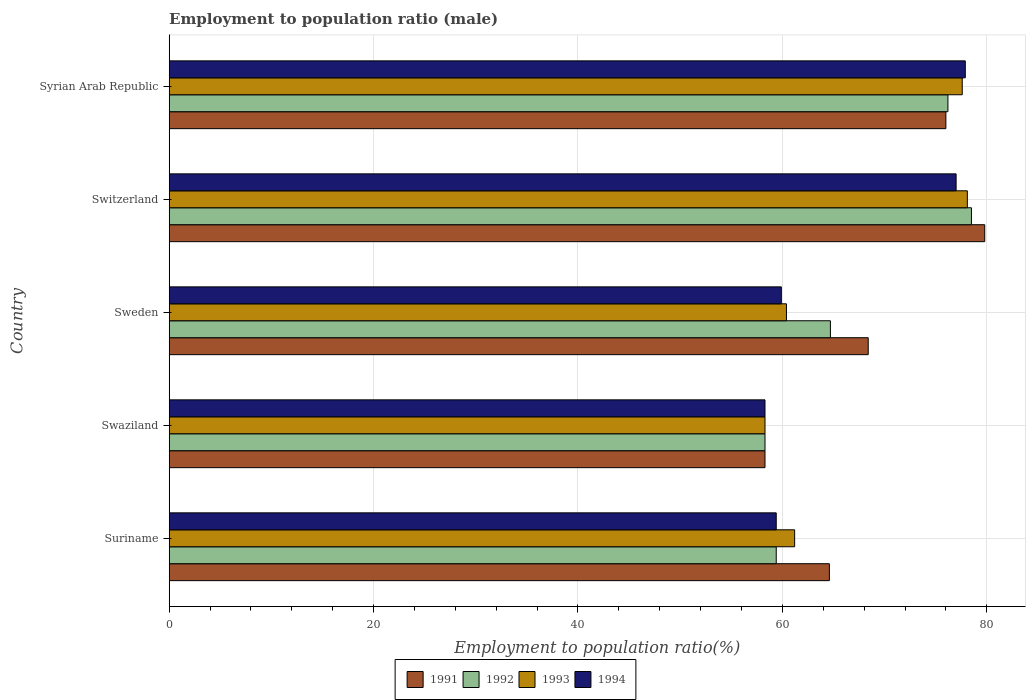How many groups of bars are there?
Your answer should be compact. 5. Are the number of bars on each tick of the Y-axis equal?
Your answer should be very brief. Yes. How many bars are there on the 5th tick from the top?
Provide a succinct answer. 4. What is the label of the 1st group of bars from the top?
Your response must be concise. Syrian Arab Republic. What is the employment to population ratio in 1992 in Syrian Arab Republic?
Make the answer very short. 76.2. Across all countries, what is the maximum employment to population ratio in 1993?
Keep it short and to the point. 78.1. Across all countries, what is the minimum employment to population ratio in 1993?
Provide a succinct answer. 58.3. In which country was the employment to population ratio in 1993 maximum?
Ensure brevity in your answer.  Switzerland. In which country was the employment to population ratio in 1992 minimum?
Keep it short and to the point. Swaziland. What is the total employment to population ratio in 1991 in the graph?
Your response must be concise. 347.1. What is the difference between the employment to population ratio in 1994 in Suriname and that in Sweden?
Make the answer very short. -0.5. What is the difference between the employment to population ratio in 1991 in Syrian Arab Republic and the employment to population ratio in 1992 in Suriname?
Ensure brevity in your answer.  16.6. What is the average employment to population ratio in 1994 per country?
Offer a terse response. 66.5. What is the difference between the employment to population ratio in 1994 and employment to population ratio in 1992 in Syrian Arab Republic?
Make the answer very short. 1.7. In how many countries, is the employment to population ratio in 1994 greater than 64 %?
Your answer should be very brief. 2. What is the ratio of the employment to population ratio in 1992 in Swaziland to that in Switzerland?
Make the answer very short. 0.74. Is the employment to population ratio in 1991 in Suriname less than that in Sweden?
Your response must be concise. Yes. Is the difference between the employment to population ratio in 1994 in Suriname and Sweden greater than the difference between the employment to population ratio in 1992 in Suriname and Sweden?
Your answer should be compact. Yes. What is the difference between the highest and the second highest employment to population ratio in 1991?
Your answer should be compact. 3.8. What is the difference between the highest and the lowest employment to population ratio in 1993?
Offer a very short reply. 19.8. What does the 2nd bar from the top in Suriname represents?
Keep it short and to the point. 1993. Is it the case that in every country, the sum of the employment to population ratio in 1992 and employment to population ratio in 1991 is greater than the employment to population ratio in 1994?
Your answer should be very brief. Yes. How many bars are there?
Your answer should be compact. 20. Are all the bars in the graph horizontal?
Keep it short and to the point. Yes. What is the difference between two consecutive major ticks on the X-axis?
Your response must be concise. 20. Are the values on the major ticks of X-axis written in scientific E-notation?
Your response must be concise. No. Does the graph contain any zero values?
Your answer should be very brief. No. Where does the legend appear in the graph?
Your answer should be compact. Bottom center. How are the legend labels stacked?
Your answer should be very brief. Horizontal. What is the title of the graph?
Offer a terse response. Employment to population ratio (male). What is the label or title of the X-axis?
Your answer should be very brief. Employment to population ratio(%). What is the Employment to population ratio(%) of 1991 in Suriname?
Provide a short and direct response. 64.6. What is the Employment to population ratio(%) in 1992 in Suriname?
Give a very brief answer. 59.4. What is the Employment to population ratio(%) of 1993 in Suriname?
Your answer should be very brief. 61.2. What is the Employment to population ratio(%) in 1994 in Suriname?
Provide a short and direct response. 59.4. What is the Employment to population ratio(%) in 1991 in Swaziland?
Keep it short and to the point. 58.3. What is the Employment to population ratio(%) in 1992 in Swaziland?
Offer a terse response. 58.3. What is the Employment to population ratio(%) in 1993 in Swaziland?
Ensure brevity in your answer.  58.3. What is the Employment to population ratio(%) of 1994 in Swaziland?
Provide a short and direct response. 58.3. What is the Employment to population ratio(%) of 1991 in Sweden?
Provide a succinct answer. 68.4. What is the Employment to population ratio(%) in 1992 in Sweden?
Your answer should be very brief. 64.7. What is the Employment to population ratio(%) in 1993 in Sweden?
Your response must be concise. 60.4. What is the Employment to population ratio(%) of 1994 in Sweden?
Provide a succinct answer. 59.9. What is the Employment to population ratio(%) of 1991 in Switzerland?
Your answer should be very brief. 79.8. What is the Employment to population ratio(%) in 1992 in Switzerland?
Your response must be concise. 78.5. What is the Employment to population ratio(%) of 1993 in Switzerland?
Provide a succinct answer. 78.1. What is the Employment to population ratio(%) of 1994 in Switzerland?
Your response must be concise. 77. What is the Employment to population ratio(%) of 1991 in Syrian Arab Republic?
Ensure brevity in your answer.  76. What is the Employment to population ratio(%) in 1992 in Syrian Arab Republic?
Offer a terse response. 76.2. What is the Employment to population ratio(%) in 1993 in Syrian Arab Republic?
Provide a succinct answer. 77.6. What is the Employment to population ratio(%) in 1994 in Syrian Arab Republic?
Give a very brief answer. 77.9. Across all countries, what is the maximum Employment to population ratio(%) in 1991?
Ensure brevity in your answer.  79.8. Across all countries, what is the maximum Employment to population ratio(%) in 1992?
Your answer should be very brief. 78.5. Across all countries, what is the maximum Employment to population ratio(%) in 1993?
Keep it short and to the point. 78.1. Across all countries, what is the maximum Employment to population ratio(%) in 1994?
Offer a very short reply. 77.9. Across all countries, what is the minimum Employment to population ratio(%) of 1991?
Provide a succinct answer. 58.3. Across all countries, what is the minimum Employment to population ratio(%) in 1992?
Offer a very short reply. 58.3. Across all countries, what is the minimum Employment to population ratio(%) in 1993?
Make the answer very short. 58.3. Across all countries, what is the minimum Employment to population ratio(%) of 1994?
Your answer should be very brief. 58.3. What is the total Employment to population ratio(%) in 1991 in the graph?
Give a very brief answer. 347.1. What is the total Employment to population ratio(%) of 1992 in the graph?
Keep it short and to the point. 337.1. What is the total Employment to population ratio(%) of 1993 in the graph?
Provide a short and direct response. 335.6. What is the total Employment to population ratio(%) in 1994 in the graph?
Provide a succinct answer. 332.5. What is the difference between the Employment to population ratio(%) of 1993 in Suriname and that in Swaziland?
Ensure brevity in your answer.  2.9. What is the difference between the Employment to population ratio(%) of 1991 in Suriname and that in Sweden?
Provide a succinct answer. -3.8. What is the difference between the Employment to population ratio(%) in 1992 in Suriname and that in Sweden?
Provide a short and direct response. -5.3. What is the difference between the Employment to population ratio(%) in 1993 in Suriname and that in Sweden?
Your answer should be very brief. 0.8. What is the difference between the Employment to population ratio(%) of 1994 in Suriname and that in Sweden?
Your answer should be compact. -0.5. What is the difference between the Employment to population ratio(%) of 1991 in Suriname and that in Switzerland?
Your response must be concise. -15.2. What is the difference between the Employment to population ratio(%) in 1992 in Suriname and that in Switzerland?
Provide a short and direct response. -19.1. What is the difference between the Employment to population ratio(%) in 1993 in Suriname and that in Switzerland?
Keep it short and to the point. -16.9. What is the difference between the Employment to population ratio(%) in 1994 in Suriname and that in Switzerland?
Provide a short and direct response. -17.6. What is the difference between the Employment to population ratio(%) in 1991 in Suriname and that in Syrian Arab Republic?
Make the answer very short. -11.4. What is the difference between the Employment to population ratio(%) of 1992 in Suriname and that in Syrian Arab Republic?
Offer a terse response. -16.8. What is the difference between the Employment to population ratio(%) of 1993 in Suriname and that in Syrian Arab Republic?
Offer a very short reply. -16.4. What is the difference between the Employment to population ratio(%) in 1994 in Suriname and that in Syrian Arab Republic?
Provide a short and direct response. -18.5. What is the difference between the Employment to population ratio(%) of 1994 in Swaziland and that in Sweden?
Ensure brevity in your answer.  -1.6. What is the difference between the Employment to population ratio(%) of 1991 in Swaziland and that in Switzerland?
Provide a succinct answer. -21.5. What is the difference between the Employment to population ratio(%) of 1992 in Swaziland and that in Switzerland?
Offer a very short reply. -20.2. What is the difference between the Employment to population ratio(%) in 1993 in Swaziland and that in Switzerland?
Your answer should be compact. -19.8. What is the difference between the Employment to population ratio(%) of 1994 in Swaziland and that in Switzerland?
Ensure brevity in your answer.  -18.7. What is the difference between the Employment to population ratio(%) in 1991 in Swaziland and that in Syrian Arab Republic?
Your answer should be compact. -17.7. What is the difference between the Employment to population ratio(%) of 1992 in Swaziland and that in Syrian Arab Republic?
Offer a terse response. -17.9. What is the difference between the Employment to population ratio(%) in 1993 in Swaziland and that in Syrian Arab Republic?
Offer a very short reply. -19.3. What is the difference between the Employment to population ratio(%) in 1994 in Swaziland and that in Syrian Arab Republic?
Your response must be concise. -19.6. What is the difference between the Employment to population ratio(%) in 1991 in Sweden and that in Switzerland?
Provide a short and direct response. -11.4. What is the difference between the Employment to population ratio(%) in 1993 in Sweden and that in Switzerland?
Offer a very short reply. -17.7. What is the difference between the Employment to population ratio(%) in 1994 in Sweden and that in Switzerland?
Make the answer very short. -17.1. What is the difference between the Employment to population ratio(%) of 1992 in Sweden and that in Syrian Arab Republic?
Offer a very short reply. -11.5. What is the difference between the Employment to population ratio(%) in 1993 in Sweden and that in Syrian Arab Republic?
Keep it short and to the point. -17.2. What is the difference between the Employment to population ratio(%) of 1991 in Switzerland and that in Syrian Arab Republic?
Give a very brief answer. 3.8. What is the difference between the Employment to population ratio(%) of 1993 in Switzerland and that in Syrian Arab Republic?
Your answer should be very brief. 0.5. What is the difference between the Employment to population ratio(%) of 1991 in Suriname and the Employment to population ratio(%) of 1993 in Swaziland?
Your answer should be very brief. 6.3. What is the difference between the Employment to population ratio(%) of 1991 in Suriname and the Employment to population ratio(%) of 1994 in Swaziland?
Provide a short and direct response. 6.3. What is the difference between the Employment to population ratio(%) of 1991 in Suriname and the Employment to population ratio(%) of 1992 in Sweden?
Keep it short and to the point. -0.1. What is the difference between the Employment to population ratio(%) of 1991 in Suriname and the Employment to population ratio(%) of 1994 in Sweden?
Offer a terse response. 4.7. What is the difference between the Employment to population ratio(%) of 1992 in Suriname and the Employment to population ratio(%) of 1994 in Sweden?
Provide a short and direct response. -0.5. What is the difference between the Employment to population ratio(%) of 1993 in Suriname and the Employment to population ratio(%) of 1994 in Sweden?
Offer a terse response. 1.3. What is the difference between the Employment to population ratio(%) of 1991 in Suriname and the Employment to population ratio(%) of 1993 in Switzerland?
Give a very brief answer. -13.5. What is the difference between the Employment to population ratio(%) in 1992 in Suriname and the Employment to population ratio(%) in 1993 in Switzerland?
Your answer should be very brief. -18.7. What is the difference between the Employment to population ratio(%) in 1992 in Suriname and the Employment to population ratio(%) in 1994 in Switzerland?
Ensure brevity in your answer.  -17.6. What is the difference between the Employment to population ratio(%) of 1993 in Suriname and the Employment to population ratio(%) of 1994 in Switzerland?
Provide a succinct answer. -15.8. What is the difference between the Employment to population ratio(%) in 1991 in Suriname and the Employment to population ratio(%) in 1993 in Syrian Arab Republic?
Ensure brevity in your answer.  -13. What is the difference between the Employment to population ratio(%) in 1992 in Suriname and the Employment to population ratio(%) in 1993 in Syrian Arab Republic?
Your response must be concise. -18.2. What is the difference between the Employment to population ratio(%) of 1992 in Suriname and the Employment to population ratio(%) of 1994 in Syrian Arab Republic?
Offer a very short reply. -18.5. What is the difference between the Employment to population ratio(%) of 1993 in Suriname and the Employment to population ratio(%) of 1994 in Syrian Arab Republic?
Keep it short and to the point. -16.7. What is the difference between the Employment to population ratio(%) of 1991 in Swaziland and the Employment to population ratio(%) of 1993 in Sweden?
Give a very brief answer. -2.1. What is the difference between the Employment to population ratio(%) of 1991 in Swaziland and the Employment to population ratio(%) of 1994 in Sweden?
Offer a very short reply. -1.6. What is the difference between the Employment to population ratio(%) in 1992 in Swaziland and the Employment to population ratio(%) in 1994 in Sweden?
Your response must be concise. -1.6. What is the difference between the Employment to population ratio(%) of 1993 in Swaziland and the Employment to population ratio(%) of 1994 in Sweden?
Offer a terse response. -1.6. What is the difference between the Employment to population ratio(%) in 1991 in Swaziland and the Employment to population ratio(%) in 1992 in Switzerland?
Give a very brief answer. -20.2. What is the difference between the Employment to population ratio(%) of 1991 in Swaziland and the Employment to population ratio(%) of 1993 in Switzerland?
Your answer should be compact. -19.8. What is the difference between the Employment to population ratio(%) of 1991 in Swaziland and the Employment to population ratio(%) of 1994 in Switzerland?
Your response must be concise. -18.7. What is the difference between the Employment to population ratio(%) in 1992 in Swaziland and the Employment to population ratio(%) in 1993 in Switzerland?
Offer a very short reply. -19.8. What is the difference between the Employment to population ratio(%) in 1992 in Swaziland and the Employment to population ratio(%) in 1994 in Switzerland?
Your answer should be very brief. -18.7. What is the difference between the Employment to population ratio(%) in 1993 in Swaziland and the Employment to population ratio(%) in 1994 in Switzerland?
Make the answer very short. -18.7. What is the difference between the Employment to population ratio(%) of 1991 in Swaziland and the Employment to population ratio(%) of 1992 in Syrian Arab Republic?
Offer a very short reply. -17.9. What is the difference between the Employment to population ratio(%) of 1991 in Swaziland and the Employment to population ratio(%) of 1993 in Syrian Arab Republic?
Your answer should be compact. -19.3. What is the difference between the Employment to population ratio(%) of 1991 in Swaziland and the Employment to population ratio(%) of 1994 in Syrian Arab Republic?
Your answer should be very brief. -19.6. What is the difference between the Employment to population ratio(%) in 1992 in Swaziland and the Employment to population ratio(%) in 1993 in Syrian Arab Republic?
Your answer should be compact. -19.3. What is the difference between the Employment to population ratio(%) in 1992 in Swaziland and the Employment to population ratio(%) in 1994 in Syrian Arab Republic?
Ensure brevity in your answer.  -19.6. What is the difference between the Employment to population ratio(%) of 1993 in Swaziland and the Employment to population ratio(%) of 1994 in Syrian Arab Republic?
Offer a terse response. -19.6. What is the difference between the Employment to population ratio(%) in 1991 in Sweden and the Employment to population ratio(%) in 1993 in Switzerland?
Ensure brevity in your answer.  -9.7. What is the difference between the Employment to population ratio(%) of 1992 in Sweden and the Employment to population ratio(%) of 1993 in Switzerland?
Offer a very short reply. -13.4. What is the difference between the Employment to population ratio(%) of 1993 in Sweden and the Employment to population ratio(%) of 1994 in Switzerland?
Provide a succinct answer. -16.6. What is the difference between the Employment to population ratio(%) in 1991 in Sweden and the Employment to population ratio(%) in 1992 in Syrian Arab Republic?
Keep it short and to the point. -7.8. What is the difference between the Employment to population ratio(%) of 1992 in Sweden and the Employment to population ratio(%) of 1994 in Syrian Arab Republic?
Offer a very short reply. -13.2. What is the difference between the Employment to population ratio(%) of 1993 in Sweden and the Employment to population ratio(%) of 1994 in Syrian Arab Republic?
Make the answer very short. -17.5. What is the difference between the Employment to population ratio(%) of 1991 in Switzerland and the Employment to population ratio(%) of 1993 in Syrian Arab Republic?
Your response must be concise. 2.2. What is the difference between the Employment to population ratio(%) of 1992 in Switzerland and the Employment to population ratio(%) of 1993 in Syrian Arab Republic?
Give a very brief answer. 0.9. What is the average Employment to population ratio(%) in 1991 per country?
Your response must be concise. 69.42. What is the average Employment to population ratio(%) in 1992 per country?
Provide a short and direct response. 67.42. What is the average Employment to population ratio(%) in 1993 per country?
Keep it short and to the point. 67.12. What is the average Employment to population ratio(%) of 1994 per country?
Ensure brevity in your answer.  66.5. What is the difference between the Employment to population ratio(%) in 1991 and Employment to population ratio(%) in 1993 in Suriname?
Keep it short and to the point. 3.4. What is the difference between the Employment to population ratio(%) in 1991 and Employment to population ratio(%) in 1994 in Suriname?
Offer a terse response. 5.2. What is the difference between the Employment to population ratio(%) in 1992 and Employment to population ratio(%) in 1993 in Suriname?
Your response must be concise. -1.8. What is the difference between the Employment to population ratio(%) of 1992 and Employment to population ratio(%) of 1994 in Suriname?
Your answer should be compact. 0. What is the difference between the Employment to population ratio(%) of 1991 and Employment to population ratio(%) of 1992 in Swaziland?
Your response must be concise. 0. What is the difference between the Employment to population ratio(%) of 1991 and Employment to population ratio(%) of 1993 in Swaziland?
Offer a very short reply. 0. What is the difference between the Employment to population ratio(%) in 1991 and Employment to population ratio(%) in 1992 in Sweden?
Your response must be concise. 3.7. What is the difference between the Employment to population ratio(%) in 1992 and Employment to population ratio(%) in 1993 in Sweden?
Provide a short and direct response. 4.3. What is the difference between the Employment to population ratio(%) of 1992 and Employment to population ratio(%) of 1994 in Sweden?
Provide a short and direct response. 4.8. What is the difference between the Employment to population ratio(%) of 1993 and Employment to population ratio(%) of 1994 in Sweden?
Offer a very short reply. 0.5. What is the difference between the Employment to population ratio(%) of 1991 and Employment to population ratio(%) of 1993 in Switzerland?
Make the answer very short. 1.7. What is the difference between the Employment to population ratio(%) in 1993 and Employment to population ratio(%) in 1994 in Switzerland?
Offer a terse response. 1.1. What is the difference between the Employment to population ratio(%) in 1991 and Employment to population ratio(%) in 1992 in Syrian Arab Republic?
Your answer should be compact. -0.2. What is the difference between the Employment to population ratio(%) in 1992 and Employment to population ratio(%) in 1994 in Syrian Arab Republic?
Provide a short and direct response. -1.7. What is the difference between the Employment to population ratio(%) of 1993 and Employment to population ratio(%) of 1994 in Syrian Arab Republic?
Make the answer very short. -0.3. What is the ratio of the Employment to population ratio(%) of 1991 in Suriname to that in Swaziland?
Your answer should be very brief. 1.11. What is the ratio of the Employment to population ratio(%) of 1992 in Suriname to that in Swaziland?
Offer a terse response. 1.02. What is the ratio of the Employment to population ratio(%) of 1993 in Suriname to that in Swaziland?
Provide a succinct answer. 1.05. What is the ratio of the Employment to population ratio(%) in 1994 in Suriname to that in Swaziland?
Provide a succinct answer. 1.02. What is the ratio of the Employment to population ratio(%) of 1992 in Suriname to that in Sweden?
Your answer should be very brief. 0.92. What is the ratio of the Employment to population ratio(%) of 1993 in Suriname to that in Sweden?
Your answer should be very brief. 1.01. What is the ratio of the Employment to population ratio(%) of 1994 in Suriname to that in Sweden?
Offer a very short reply. 0.99. What is the ratio of the Employment to population ratio(%) of 1991 in Suriname to that in Switzerland?
Provide a succinct answer. 0.81. What is the ratio of the Employment to population ratio(%) of 1992 in Suriname to that in Switzerland?
Provide a succinct answer. 0.76. What is the ratio of the Employment to population ratio(%) of 1993 in Suriname to that in Switzerland?
Offer a terse response. 0.78. What is the ratio of the Employment to population ratio(%) in 1994 in Suriname to that in Switzerland?
Your answer should be very brief. 0.77. What is the ratio of the Employment to population ratio(%) of 1992 in Suriname to that in Syrian Arab Republic?
Your answer should be very brief. 0.78. What is the ratio of the Employment to population ratio(%) in 1993 in Suriname to that in Syrian Arab Republic?
Provide a succinct answer. 0.79. What is the ratio of the Employment to population ratio(%) of 1994 in Suriname to that in Syrian Arab Republic?
Offer a very short reply. 0.76. What is the ratio of the Employment to population ratio(%) in 1991 in Swaziland to that in Sweden?
Give a very brief answer. 0.85. What is the ratio of the Employment to population ratio(%) of 1992 in Swaziland to that in Sweden?
Ensure brevity in your answer.  0.9. What is the ratio of the Employment to population ratio(%) of 1993 in Swaziland to that in Sweden?
Provide a succinct answer. 0.97. What is the ratio of the Employment to population ratio(%) of 1994 in Swaziland to that in Sweden?
Keep it short and to the point. 0.97. What is the ratio of the Employment to population ratio(%) of 1991 in Swaziland to that in Switzerland?
Your response must be concise. 0.73. What is the ratio of the Employment to population ratio(%) in 1992 in Swaziland to that in Switzerland?
Your answer should be very brief. 0.74. What is the ratio of the Employment to population ratio(%) of 1993 in Swaziland to that in Switzerland?
Provide a succinct answer. 0.75. What is the ratio of the Employment to population ratio(%) of 1994 in Swaziland to that in Switzerland?
Ensure brevity in your answer.  0.76. What is the ratio of the Employment to population ratio(%) in 1991 in Swaziland to that in Syrian Arab Republic?
Provide a succinct answer. 0.77. What is the ratio of the Employment to population ratio(%) of 1992 in Swaziland to that in Syrian Arab Republic?
Offer a very short reply. 0.77. What is the ratio of the Employment to population ratio(%) in 1993 in Swaziland to that in Syrian Arab Republic?
Make the answer very short. 0.75. What is the ratio of the Employment to population ratio(%) of 1994 in Swaziland to that in Syrian Arab Republic?
Offer a very short reply. 0.75. What is the ratio of the Employment to population ratio(%) of 1991 in Sweden to that in Switzerland?
Your answer should be very brief. 0.86. What is the ratio of the Employment to population ratio(%) of 1992 in Sweden to that in Switzerland?
Your answer should be compact. 0.82. What is the ratio of the Employment to population ratio(%) in 1993 in Sweden to that in Switzerland?
Give a very brief answer. 0.77. What is the ratio of the Employment to population ratio(%) of 1994 in Sweden to that in Switzerland?
Ensure brevity in your answer.  0.78. What is the ratio of the Employment to population ratio(%) of 1992 in Sweden to that in Syrian Arab Republic?
Keep it short and to the point. 0.85. What is the ratio of the Employment to population ratio(%) of 1993 in Sweden to that in Syrian Arab Republic?
Ensure brevity in your answer.  0.78. What is the ratio of the Employment to population ratio(%) of 1994 in Sweden to that in Syrian Arab Republic?
Ensure brevity in your answer.  0.77. What is the ratio of the Employment to population ratio(%) in 1991 in Switzerland to that in Syrian Arab Republic?
Your answer should be compact. 1.05. What is the ratio of the Employment to population ratio(%) of 1992 in Switzerland to that in Syrian Arab Republic?
Ensure brevity in your answer.  1.03. What is the ratio of the Employment to population ratio(%) in 1993 in Switzerland to that in Syrian Arab Republic?
Keep it short and to the point. 1.01. What is the ratio of the Employment to population ratio(%) in 1994 in Switzerland to that in Syrian Arab Republic?
Your answer should be very brief. 0.99. What is the difference between the highest and the second highest Employment to population ratio(%) of 1993?
Give a very brief answer. 0.5. What is the difference between the highest and the second highest Employment to population ratio(%) in 1994?
Ensure brevity in your answer.  0.9. What is the difference between the highest and the lowest Employment to population ratio(%) in 1992?
Your answer should be very brief. 20.2. What is the difference between the highest and the lowest Employment to population ratio(%) of 1993?
Ensure brevity in your answer.  19.8. What is the difference between the highest and the lowest Employment to population ratio(%) in 1994?
Ensure brevity in your answer.  19.6. 